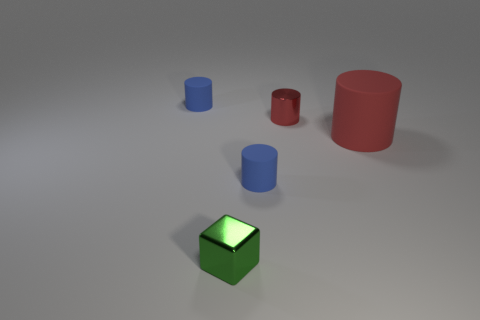The metal object that is the same size as the green cube is what shape?
Offer a terse response. Cylinder. Do the rubber cylinder behind the big rubber cylinder and the red cylinder that is behind the big red matte object have the same size?
Your answer should be compact. Yes. What number of large matte objects are there?
Keep it short and to the point. 1. How big is the blue thing on the right side of the shiny object that is in front of the cylinder in front of the big rubber object?
Offer a terse response. Small. Is the tiny shiny cube the same color as the small shiny cylinder?
Your response must be concise. No. Is there anything else that is the same size as the metal cylinder?
Give a very brief answer. Yes. How many green metallic things are to the left of the green block?
Give a very brief answer. 0. Are there an equal number of tiny blue rubber cylinders that are behind the large red cylinder and rubber things?
Provide a short and direct response. No. How many objects are either small blue cylinders or big gray rubber balls?
Keep it short and to the point. 2. Is there anything else that has the same shape as the small red metal object?
Your response must be concise. Yes. 